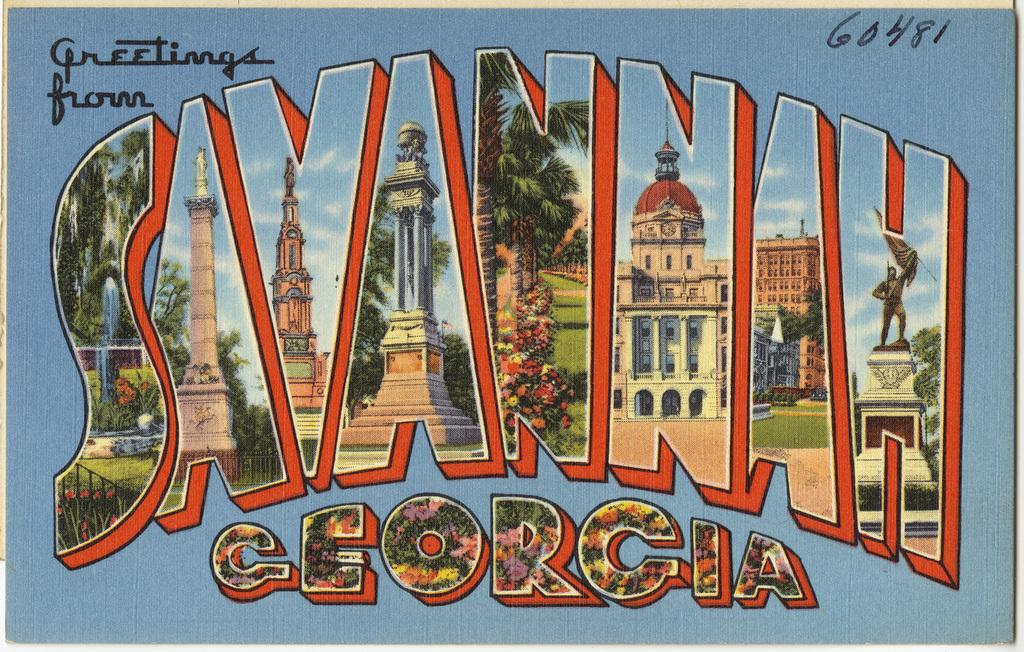<image>
Offer a succinct explanation of the picture presented. A greetings from Savannah Georgia sign numbered 60481. 